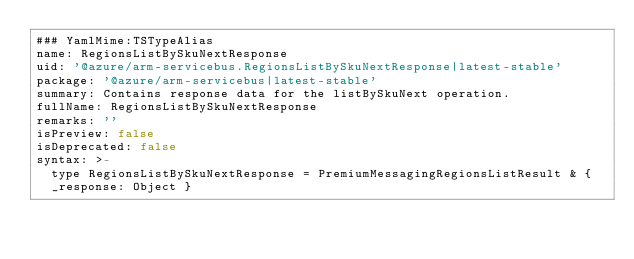Convert code to text. <code><loc_0><loc_0><loc_500><loc_500><_YAML_>### YamlMime:TSTypeAlias
name: RegionsListBySkuNextResponse
uid: '@azure/arm-servicebus.RegionsListBySkuNextResponse|latest-stable'
package: '@azure/arm-servicebus|latest-stable'
summary: Contains response data for the listBySkuNext operation.
fullName: RegionsListBySkuNextResponse
remarks: ''
isPreview: false
isDeprecated: false
syntax: >-
  type RegionsListBySkuNextResponse = PremiumMessagingRegionsListResult & {
  _response: Object }
</code> 